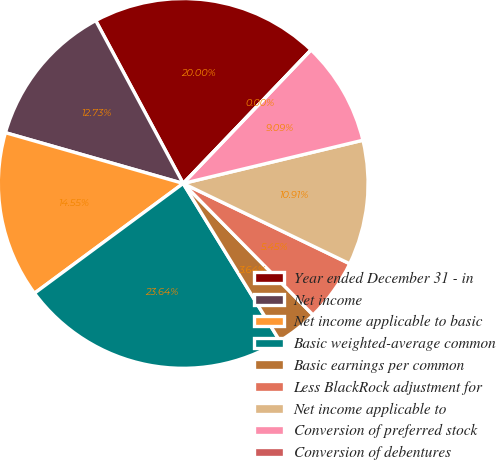Convert chart to OTSL. <chart><loc_0><loc_0><loc_500><loc_500><pie_chart><fcel>Year ended December 31 - in<fcel>Net income<fcel>Net income applicable to basic<fcel>Basic weighted-average common<fcel>Basic earnings per common<fcel>Less BlackRock adjustment for<fcel>Net income applicable to<fcel>Conversion of preferred stock<fcel>Conversion of debentures<nl><fcel>20.0%<fcel>12.73%<fcel>14.55%<fcel>23.64%<fcel>3.64%<fcel>5.45%<fcel>10.91%<fcel>9.09%<fcel>0.0%<nl></chart> 